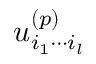Convert formula to latex. <formula><loc_0><loc_0><loc_500><loc_500>u _ { i _ { 1 } \cdots i _ { l } } ^ { ( p ) }</formula> 